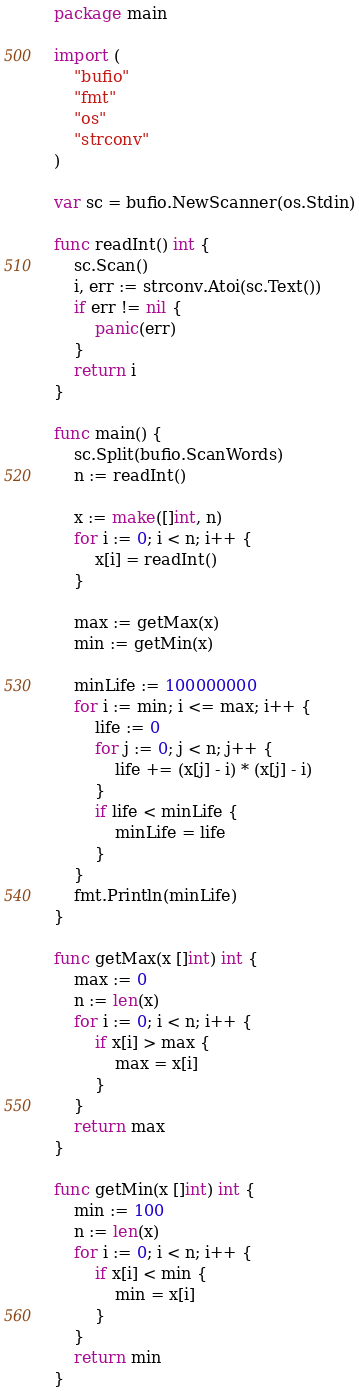Convert code to text. <code><loc_0><loc_0><loc_500><loc_500><_Go_>package main

import (
	"bufio"
	"fmt"
	"os"
	"strconv"
)

var sc = bufio.NewScanner(os.Stdin)

func readInt() int {
	sc.Scan()
	i, err := strconv.Atoi(sc.Text())
	if err != nil {
		panic(err)
	}
	return i
}

func main() {
	sc.Split(bufio.ScanWords)
	n := readInt()

	x := make([]int, n)
	for i := 0; i < n; i++ {
		x[i] = readInt()
	}

	max := getMax(x)
	min := getMin(x)

	minLife := 100000000
	for i := min; i <= max; i++ {
		life := 0
		for j := 0; j < n; j++ {
			life += (x[j] - i) * (x[j] - i)
		}
		if life < minLife {
			minLife = life
		}
	}
	fmt.Println(minLife)
}

func getMax(x []int) int {
	max := 0
	n := len(x)
	for i := 0; i < n; i++ {
		if x[i] > max {
			max = x[i]
		}
	}
	return max
}

func getMin(x []int) int {
	min := 100
	n := len(x)
	for i := 0; i < n; i++ {
		if x[i] < min {
			min = x[i]
		}
	}
	return min
}
</code> 